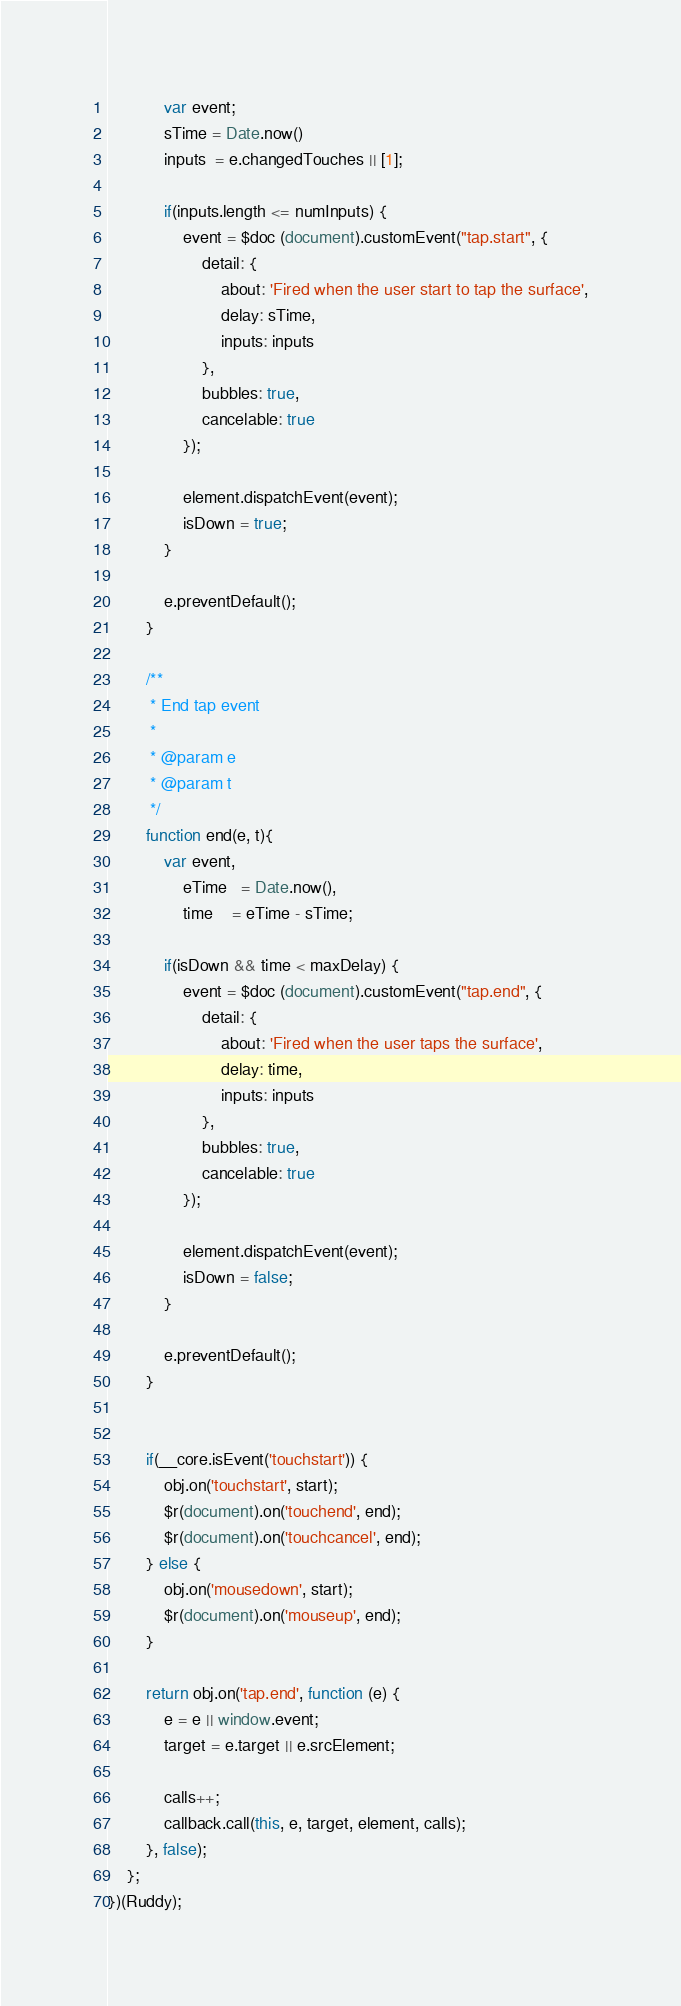<code> <loc_0><loc_0><loc_500><loc_500><_JavaScript_>            var event;
            sTime = Date.now()
            inputs  = e.changedTouches || [1];

            if(inputs.length <= numInputs) {
                event = $doc (document).customEvent("tap.start", {
                    detail: {
                        about: 'Fired when the user start to tap the surface',
                        delay: sTime,
                        inputs: inputs
                    },
                    bubbles: true,
                    cancelable: true
                });

                element.dispatchEvent(event);
                isDown = true;
            }

            e.preventDefault();
        }

        /**
         * End tap event
         *
         * @param e
         * @param t
         */
        function end(e, t){
            var event,
                eTime   = Date.now(),
                time    = eTime - sTime;

            if(isDown && time < maxDelay) {
                event = $doc (document).customEvent("tap.end", {
                    detail: {
                        about: 'Fired when the user taps the surface',
                        delay: time,
                        inputs: inputs
                    },
                    bubbles: true,
                    cancelable: true
                });

                element.dispatchEvent(event);
                isDown = false;
            }

            e.preventDefault();
        }


        if(__core.isEvent('touchstart')) {
            obj.on('touchstart', start);
            $r(document).on('touchend', end);
            $r(document).on('touchcancel', end);
        } else {
            obj.on('mousedown', start);
            $r(document).on('mouseup', end);
        }

        return obj.on('tap.end', function (e) {
            e = e || window.event;
            target = e.target || e.srcElement;

            calls++;
            callback.call(this, e, target, element, calls);
        }, false);
    };
})(Ruddy);</code> 